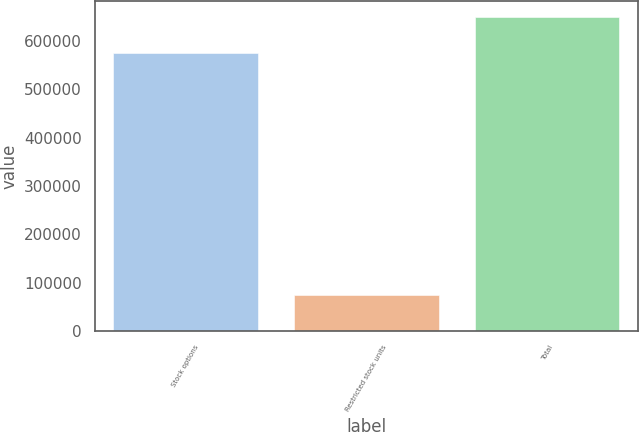Convert chart. <chart><loc_0><loc_0><loc_500><loc_500><bar_chart><fcel>Stock options<fcel>Restricted stock units<fcel>Total<nl><fcel>575266<fcel>74166<fcel>649432<nl></chart> 